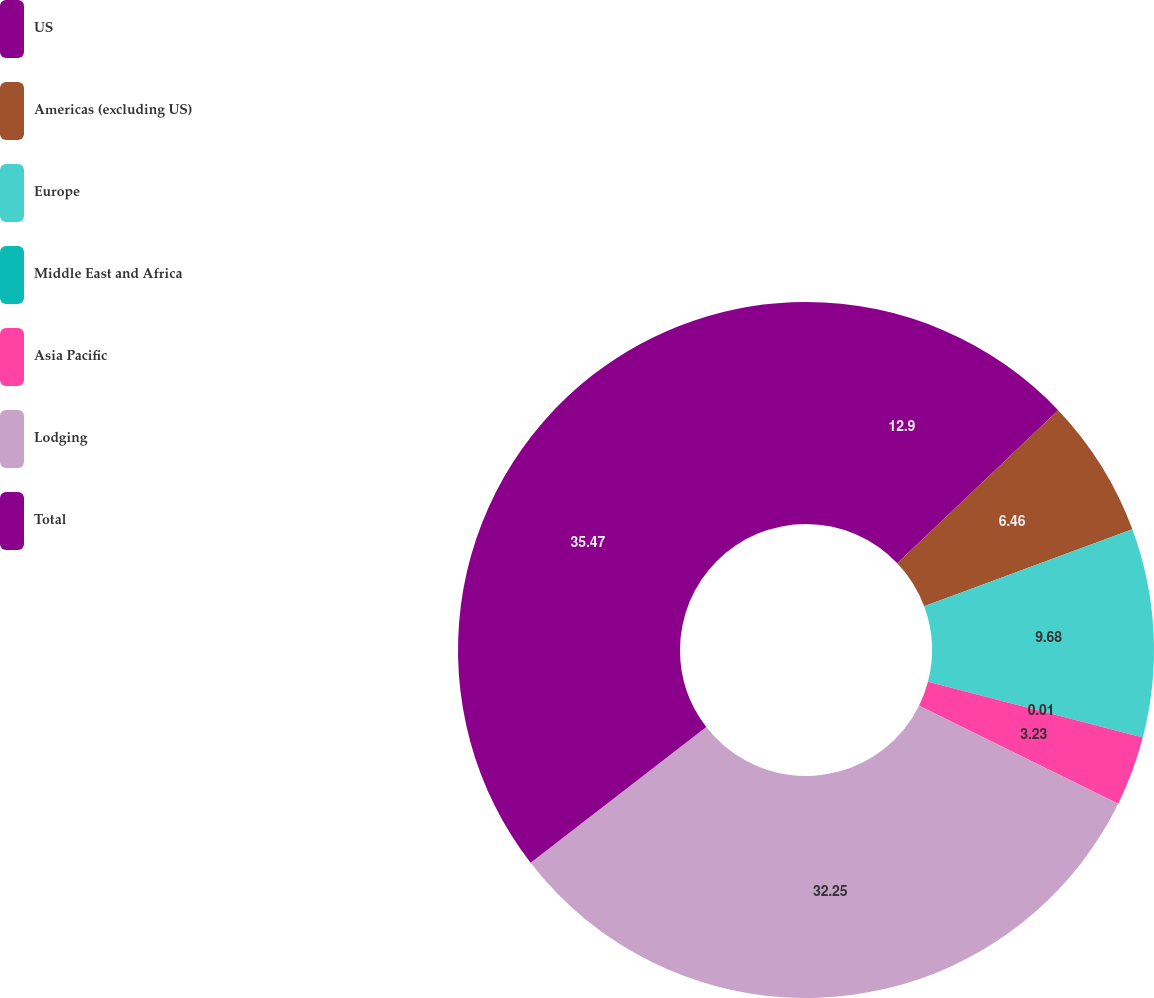Convert chart to OTSL. <chart><loc_0><loc_0><loc_500><loc_500><pie_chart><fcel>US<fcel>Americas (excluding US)<fcel>Europe<fcel>Middle East and Africa<fcel>Asia Pacific<fcel>Lodging<fcel>Total<nl><fcel>12.9%<fcel>6.46%<fcel>9.68%<fcel>0.01%<fcel>3.23%<fcel>32.25%<fcel>35.47%<nl></chart> 